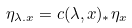<formula> <loc_0><loc_0><loc_500><loc_500>\eta _ { \lambda . x } = c ( \lambda , x ) _ { * } \eta _ { x }</formula> 